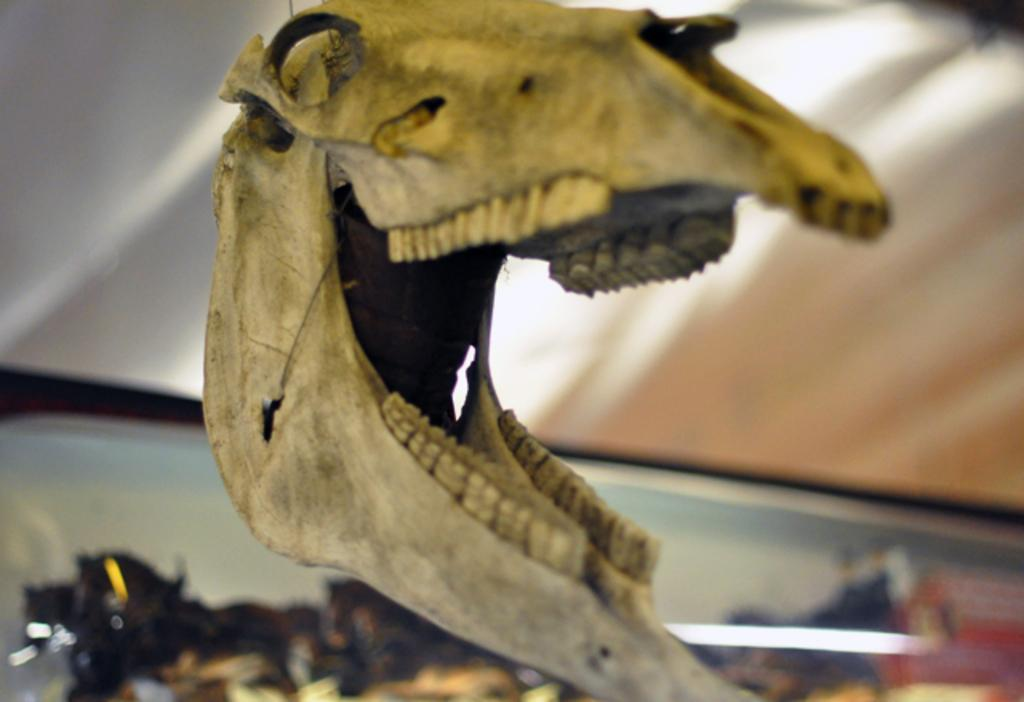What is the main subject of the image? The main subject of the image is a model of a dinosaur skull. What type of prose is being recited by the dinosaur skull in the image? There is no indication in the image that the dinosaur skull is reciting any prose, as it is a model and not a living being capable of speech. 